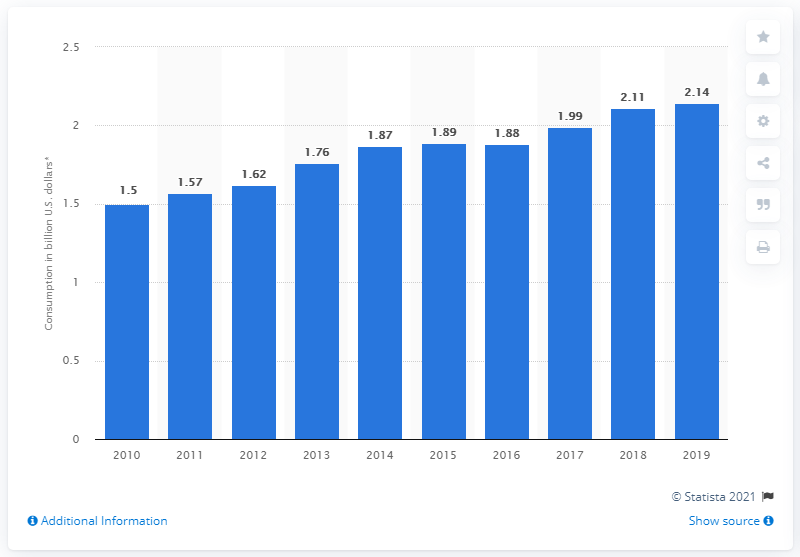Give some essential details in this illustration. In 2019, Aruba's internal consumption of travel and tourism was 2.14 billion dollars. 